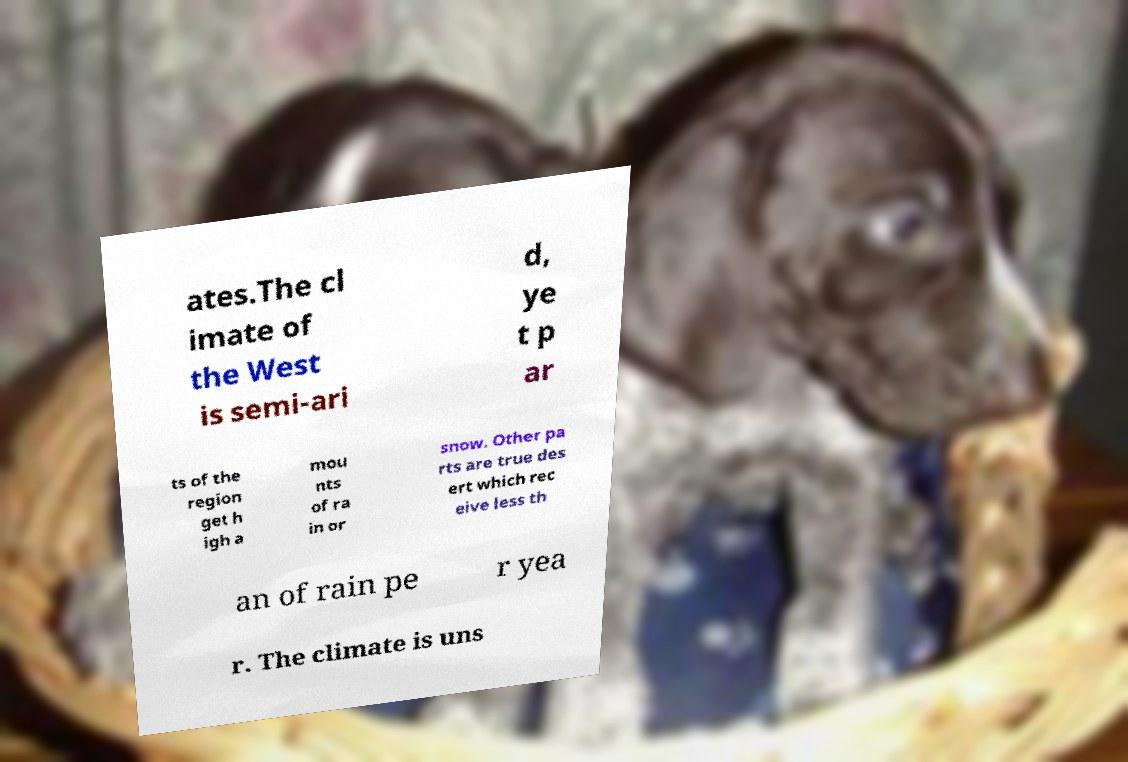Could you assist in decoding the text presented in this image and type it out clearly? ates.The cl imate of the West is semi-ari d, ye t p ar ts of the region get h igh a mou nts of ra in or snow. Other pa rts are true des ert which rec eive less th an of rain pe r yea r. The climate is uns 